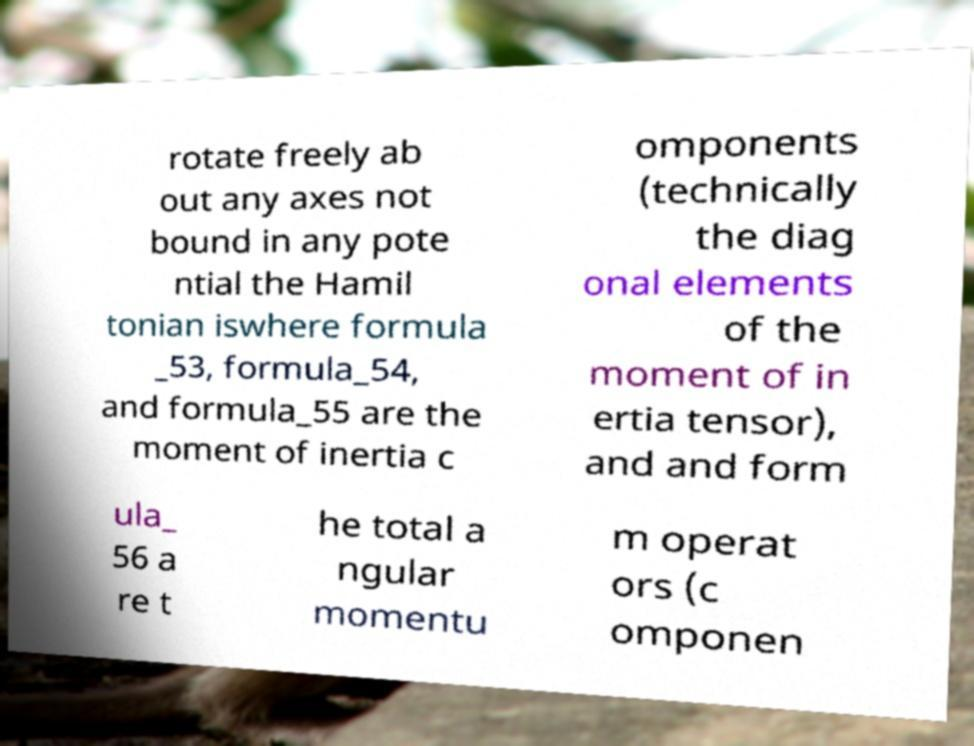Could you extract and type out the text from this image? rotate freely ab out any axes not bound in any pote ntial the Hamil tonian iswhere formula _53, formula_54, and formula_55 are the moment of inertia c omponents (technically the diag onal elements of the moment of in ertia tensor), and and form ula_ 56 a re t he total a ngular momentu m operat ors (c omponen 